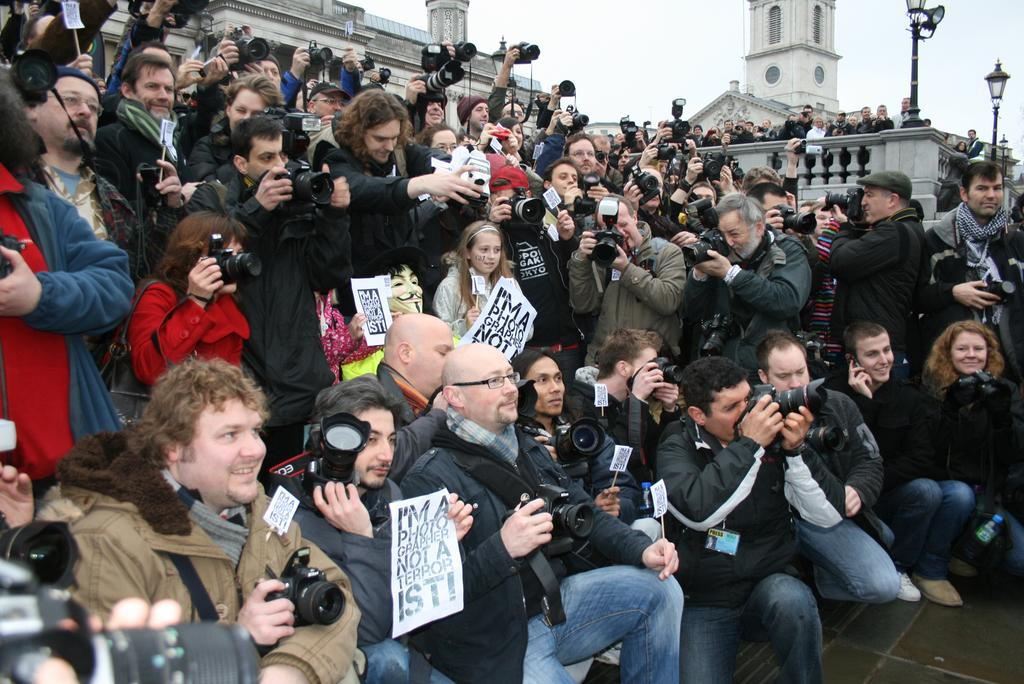How many people are in the image? There are many people in the foreground of the image. What are the people in the image doing? Some people are squatting, some are sitting, and some are standing while holding a camera. What can be seen in the background of the image? There are buildings, poles, and the sky visible in the background of the image. Can you see the root of the tree in the image? There is no tree or root present in the image. What type of ear is visible on the person in the image? There are no visible ears on the people in the image, as their faces are not shown. 